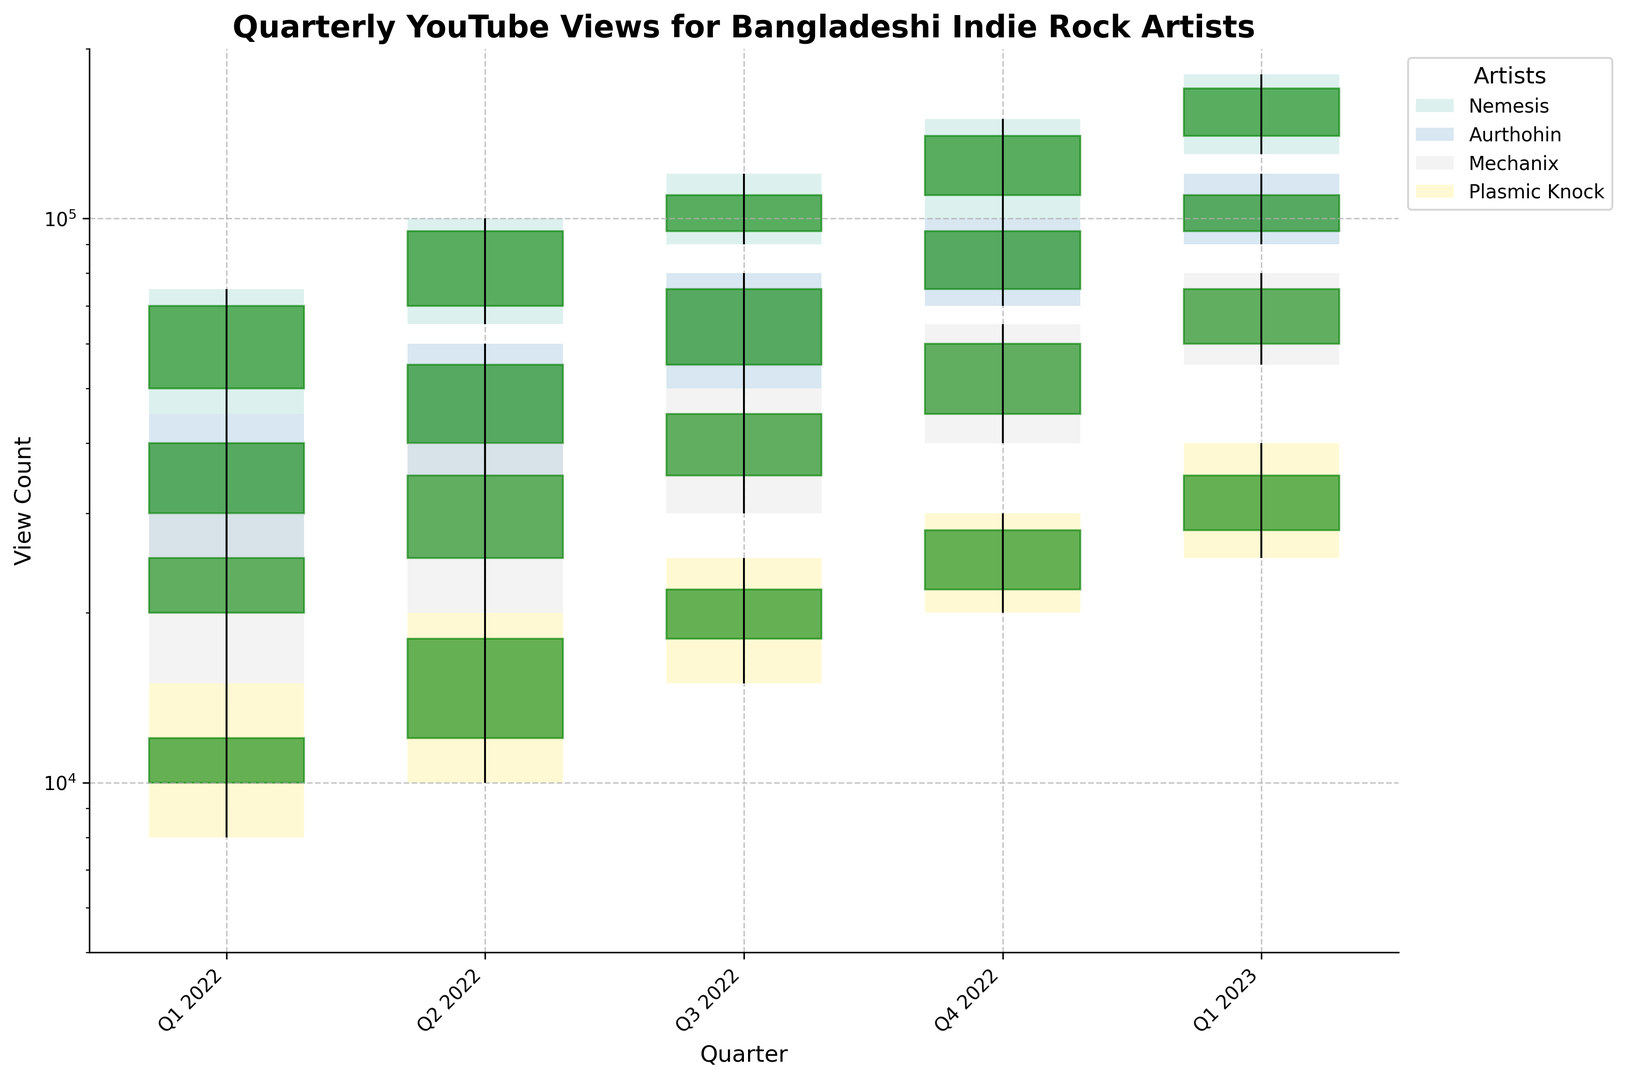Which artist saw the highest peak in view count in Q4 2022? To find the artist with the highest peak in view count, check the highest values for Q4 2022 in the highs column. For Q4 2022, Nemesis reached 150,000 views, which is the highest peak among all artists.
Answer: Nemesis How did Nemesis's view count change from Q2 2022 to Q3 2022? For Q2 2022, Nemesis started at 70,000 and ended at 95,000 views. For Q3 2022, it started at 95,000 and ended at 110,000 views. The calculation of change from the start of Q2 to the end of Q3 is 110,000 - 70,000.
Answer: Increase by 40,000 What was the range of Plasmic Knock's view counts in Q1 2023? The range is calculated by subtracting the lowest view count from the highest view count in Q1 2023. For Plasmic Knock, the low was 25,000 and the high was 40,000. The range is 40,000 - 25,000.
Answer: 15,000 Which quarter did Aurthohin surpass the 50,000 view count mark? Aurthohin surpassed the 50,000 view count mark starting in Q2 2022. Referring to the closes, in Q2 2022, Aurthohin had 55,000 views.
Answer: Q2 2022 Did Mechanix's view count show a consistent increase throughout the quarters reported? By looking at the close values for Mechanix across each quarter, the view counts are: Q1 2022 (25,000), Q2 2022 (35,000), Q3 2022 (45,000), Q4 2022 (60,000), Q1 2023 (75,000). Yes, they consistently increased each quarter.
Answer: Yes Which artist shows the steepest rise in view count in any single quarter? To determine the steepest rise, we look for the largest difference between open and close values in any single quarter. Nemesis shows the largest rise from Q4 2022 where the view count went from 110,000 to 140,000, a rise of 30,000.
Answer: Nemesis For Q1 2023, what is the average close view count for all the artists? The close values for Q1 2023 for each artist are: Nemesis (170,000), Aurthohin (110,000), Mechanix (75,000), Plasmic Knock (35,000). Average = (170,000 + 110,000 + 75,000 + 35,000)/4.
Answer: 97,500 Comparing Q2 2022 and Q3 2022, which artist had the smallest change in their close view counts? The close values for Q2 and Q3 2022 are as follows:
- Nemesis: Q2 (95,000), Q3 (110,000), change = 15,000
- Aurthohin: Q2 (55,000), Q3 (75,000), change = 20,000
- Mechanix: Q2 (35,000), Q3 (45,000), change = 10,000
- Plasmic Knock: Q2 (18,000), Q3 (22,000), change = 4,000. Plasmic Knock had the smallest change.
Answer: Plasmic Knock In Q1 2022, which artist had the highest lowest view count? Look at the lows for each artist in Q1 2022:
- Nemesis (45,000)
- Aurthohin (25,000)
- Mechanix (15,000)
- Plasmic Knock (8,000)
Nemesis had the highest lowest view count at 45,000.
Answer: Nemesis Between Nemesis and Aurthohin, which one had more stable view counts in 2022 considering the range between their highs and lows? Calculate the range for each artist throughout all quarters:
- Nemesis: ranges are 30,000 (Q1), 35,000 (Q2), 30,000 (Q3), 50,000 (Q4)
- Aurthohin: ranges are 20,000 (Q1), 25,000 (Q2), 30,000 (Q3), 30,000 (Q4)
Aurthohin has slightly more stable ranges overall, being smaller and less varying.
Answer: Aurthohin 